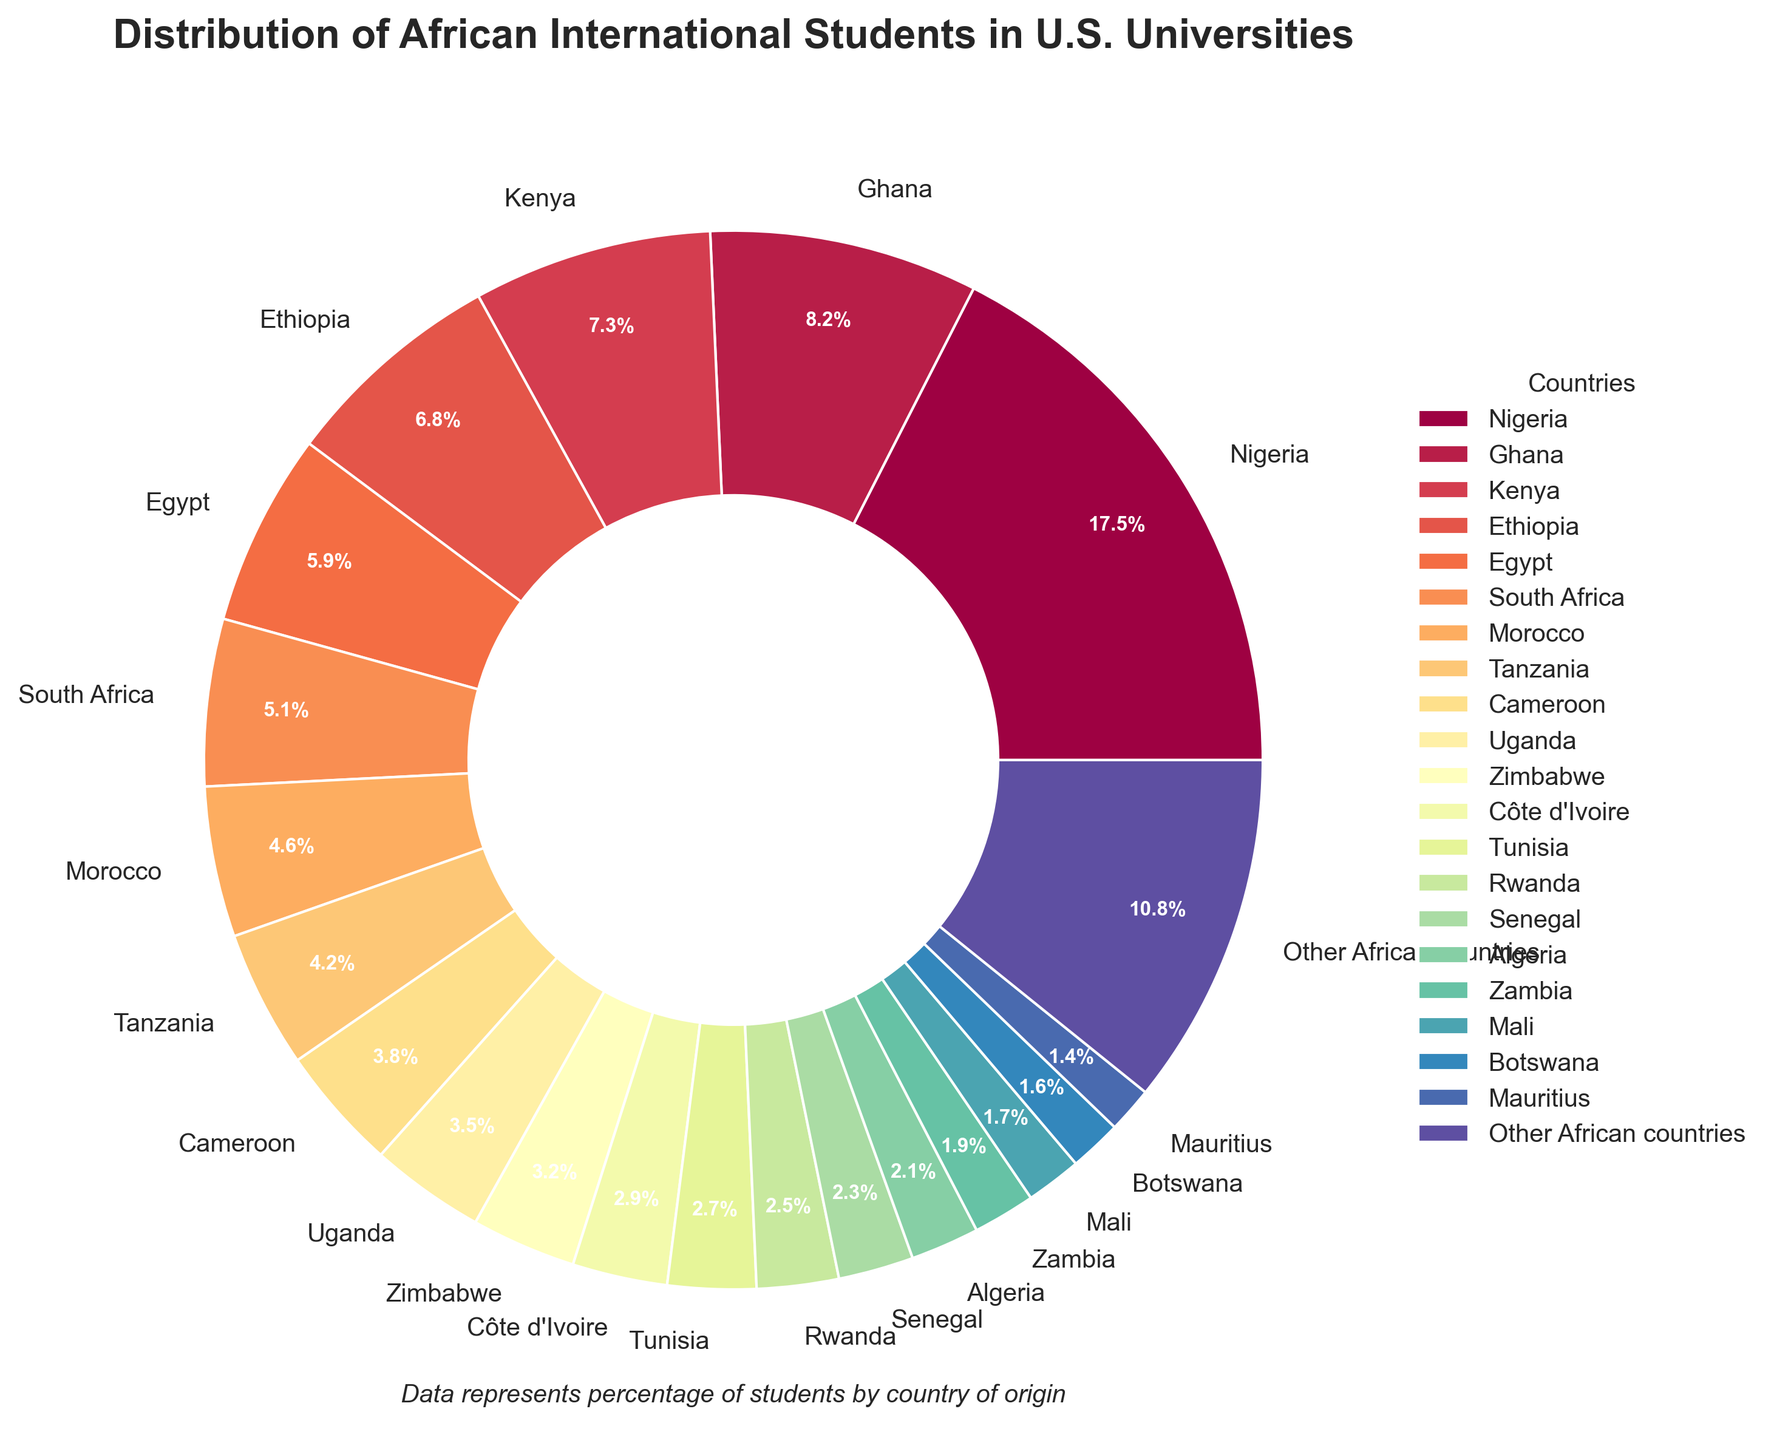Which country has the highest percentage of African international students in U.S. universities? By observing the pie chart, the largest segment is labeled as Nigeria with a percentage of 17.5%.
Answer: Nigeria What is the combined percentage of students from Ghana and Kenya? From the pie chart, Ghana has 8.2% and Kenya has 7.3%. By adding these values together, 8.2 + 7.3 = 15.5%.
Answer: 15.5% Which country has a higher percentage of students, Ethiopia or Egypt? The pie chart shows that Ethiopia has 6.8% while Egypt has 5.9%. Therefore, Ethiopia has a higher percentage.
Answer: Ethiopia How many countries have a percentage higher than 5%? By examining the pie chart, the countries with percentages higher than 5% are Nigeria (17.5%), Ghana (8.2%), Kenya (7.3%), Ethiopia (6.8%), and Egypt (5.9%). Counting these, there are 5 countries.
Answer: 5 What is the combined percentage of students from the top 3 countries? The top 3 countries in the pie chart are Nigeria (17.5%), Ghana (8.2%), and Kenya (7.3%). Adding these, 17.5 + 8.2 + 7.3 = 33%.
Answer: 33% Which has a smaller percentage, Tanzania or Cameroon, and by how much? The pie chart shows Tanzania at 4.2% and Cameroon at 3.8%. The difference is 4.2 - 3.8 = 0.4%. So, Cameroon has a smaller percentage by 0.4%.
Answer: Cameroon, 0.4% What is the percentage difference between the largest and smallest segment? The largest segment is Nigeria with 17.5% and the smallest is Mauritius with 1.4%. The difference is 17.5 - 1.4 = 16.1%.
Answer: 16.1% Do the combined percentages of South Africa and Morocco exceed 10%? The pie chart shows South Africa at 5.1% and Morocco at 4.6%. Combining these, 5.1 + 4.6 = 9.7%, which does not exceed 10%.
Answer: No, 9.7% How many countries have a percentage below 3%? By observing the pie chart, the countries with percentages below 3% are Côte d'Ivoire (2.9%), Tunisia (2.7%), Rwanda (2.5%), Senegal (2.3%), Algeria (2.1%), Zambia (1.9%), Mali (1.7%), Botswana (1.6%), and Mauritius (1.4%). Counting these, there are 9 countries.
Answer: 9 Which color represents Nigeria in the pie chart? The segment with 17.5% is the largest and corresponds to Nigeria. The specific color should be visually identified from the pie chart, typically a prominent one placed near the top of the color spectrum in the color palette used.
Answer: Visually identifiable in the chart 